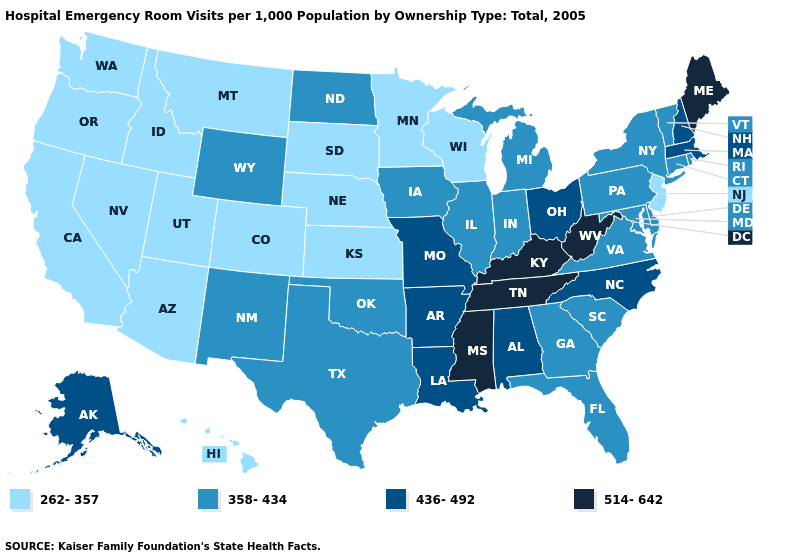Which states have the lowest value in the MidWest?
Answer briefly. Kansas, Minnesota, Nebraska, South Dakota, Wisconsin. Does the first symbol in the legend represent the smallest category?
Quick response, please. Yes. What is the value of Hawaii?
Concise answer only. 262-357. Does New Jersey have a lower value than Colorado?
Be succinct. No. Does Maine have the highest value in the Northeast?
Quick response, please. Yes. What is the value of New Jersey?
Write a very short answer. 262-357. What is the value of Virginia?
Quick response, please. 358-434. What is the value of Rhode Island?
Answer briefly. 358-434. Among the states that border New Hampshire , which have the highest value?
Short answer required. Maine. What is the value of Connecticut?
Short answer required. 358-434. Does West Virginia have the highest value in the USA?
Short answer required. Yes. What is the highest value in states that border Nebraska?
Keep it brief. 436-492. Is the legend a continuous bar?
Quick response, please. No. Does Kentucky have the highest value in the South?
Be succinct. Yes. What is the value of New York?
Be succinct. 358-434. 